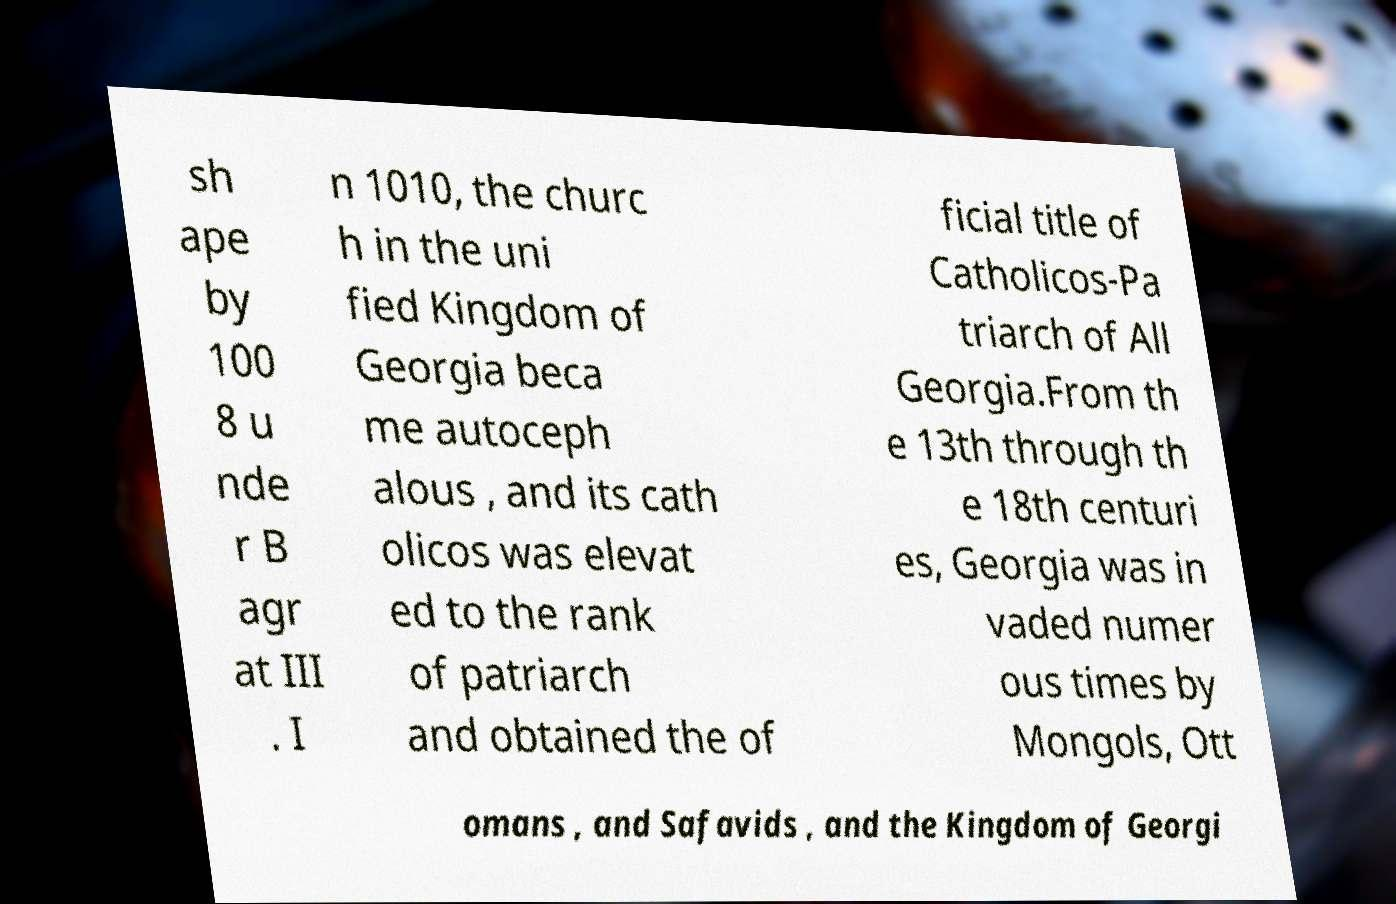Could you assist in decoding the text presented in this image and type it out clearly? sh ape by 100 8 u nde r B agr at III . I n 1010, the churc h in the uni fied Kingdom of Georgia beca me autoceph alous , and its cath olicos was elevat ed to the rank of patriarch and obtained the of ficial title of Catholicos-Pa triarch of All Georgia.From th e 13th through th e 18th centuri es, Georgia was in vaded numer ous times by Mongols, Ott omans , and Safavids , and the Kingdom of Georgi 